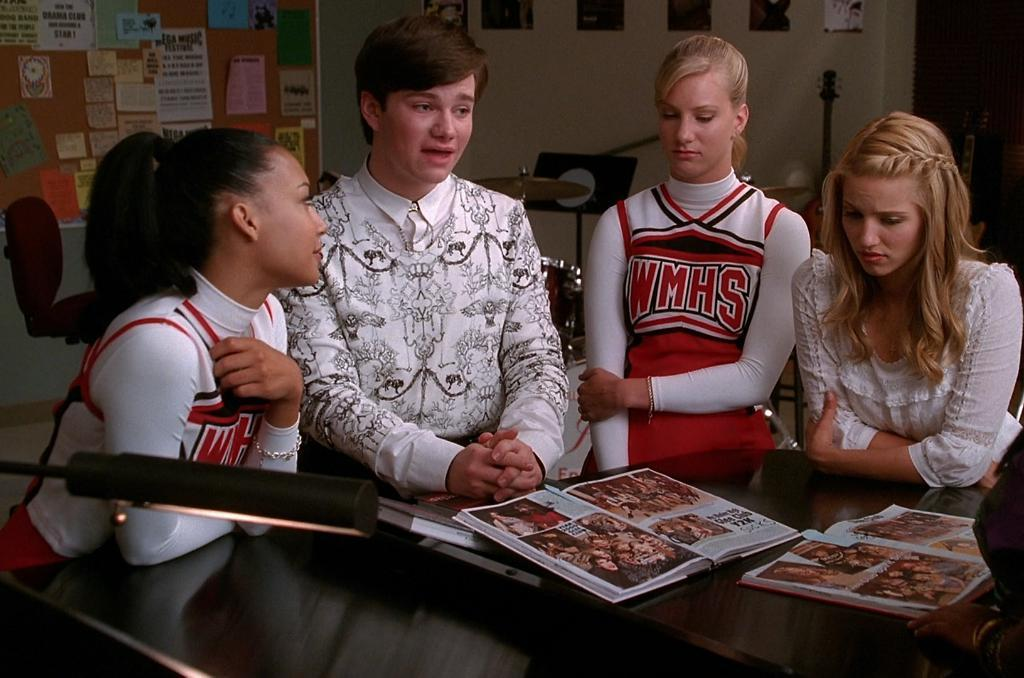<image>
Offer a succinct explanation of the picture presented. A cheerleader wearinga skirt which says WMHS talking to a group of people. 